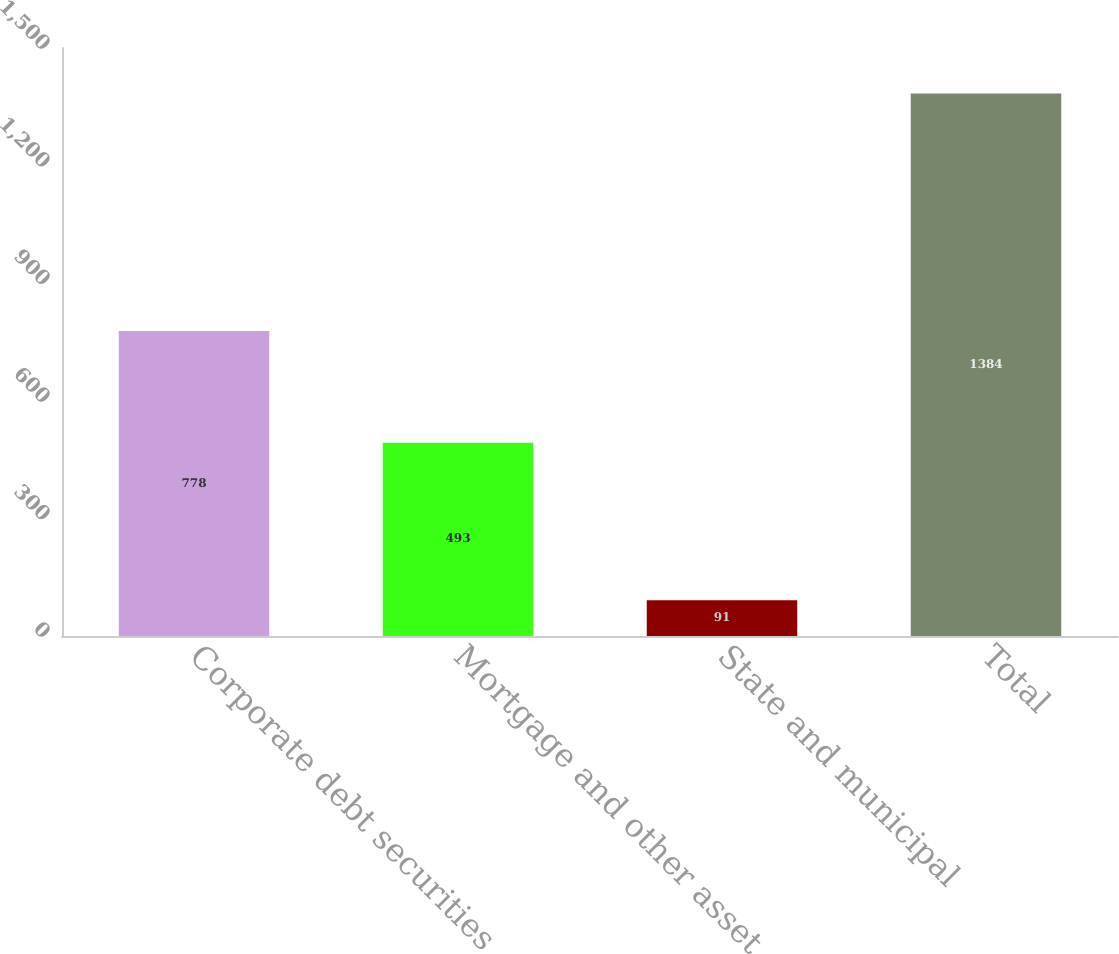Convert chart. <chart><loc_0><loc_0><loc_500><loc_500><bar_chart><fcel>Corporate debt securities<fcel>Mortgage and other asset<fcel>State and municipal<fcel>Total<nl><fcel>778<fcel>493<fcel>91<fcel>1384<nl></chart> 